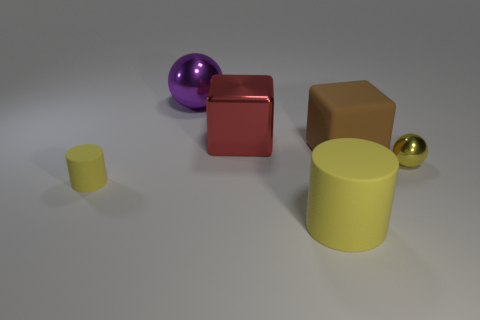What is the size of the other matte cylinder that is the same color as the big cylinder?
Make the answer very short. Small. Are there any things that have the same color as the big matte cylinder?
Offer a very short reply. Yes. How many things are either big purple matte spheres or tiny yellow matte cylinders?
Offer a terse response. 1. There is a tiny object to the left of the tiny metal thing; does it have the same color as the ball to the right of the large brown matte object?
Provide a succinct answer. Yes. Are there any large cyan matte blocks?
Give a very brief answer. No. How many things are large rubber objects or brown objects that are behind the yellow metal sphere?
Your answer should be compact. 2. There is a metal sphere that is behind the yellow sphere; is it the same size as the brown thing?
Ensure brevity in your answer.  Yes. How many other things are the same size as the matte block?
Keep it short and to the point. 3. What is the color of the big shiny ball?
Offer a very short reply. Purple. What is the yellow cylinder that is to the left of the large purple metallic ball made of?
Your answer should be compact. Rubber. 